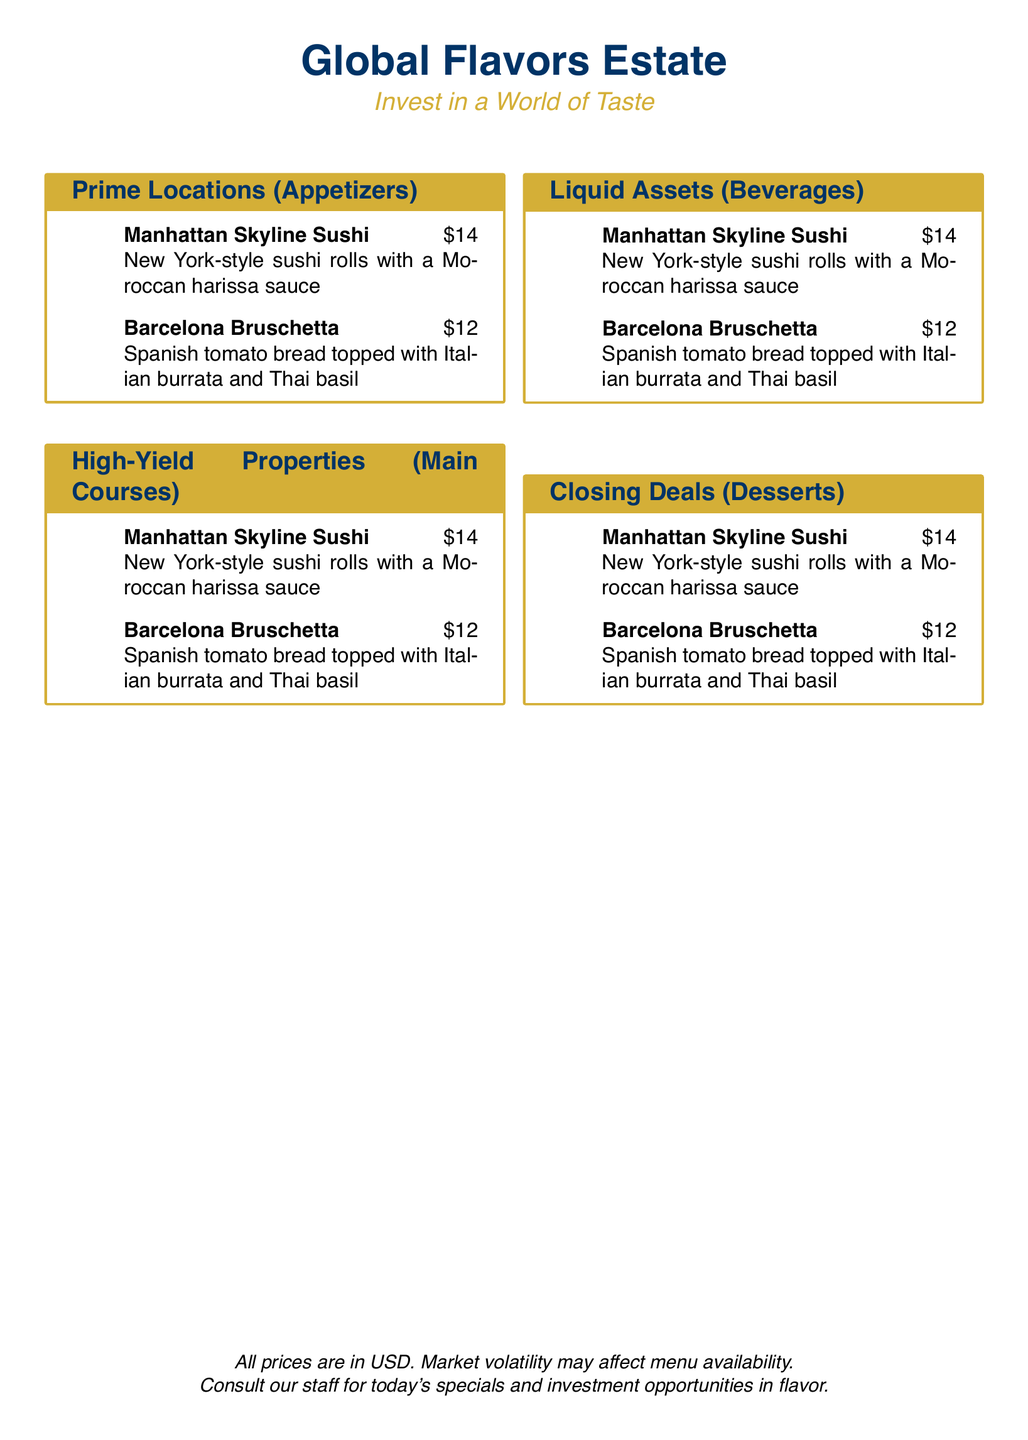What are the Prime Locations? The Prime Locations section lists appetizers, which include various starters.
Answer: Appetizers What is the price of Manhattan Skyline Sushi? The price is specifically stated next to the item in the menu.
Answer: $14 What type of sauce accompanies the Manhattan Skyline Sushi? The sauce is mentioned directly with the sushi description.
Answer: Moroccan harissa sauce Which Italian cheese is featured in the Barcelona Bruschetta? The cheese is specified in the description of the menu item.
Answer: Burrata How many appetizers are listed? The total count of the appetizers can be derived from the list under Prime Locations.
Answer: 2 What does the menu encourage customers to consult staff about? The document specifically mentions this aspect in the footer note.
Answer: Today's specials What is the color of the box that outlines each section? The color of the box is part of the design specified in the document.
Answer: Gold What is the main theme of the restaurant indicated in the title? The title of the document gives an insight into the overarching concept of the restaurant.
Answer: Global Flavors 